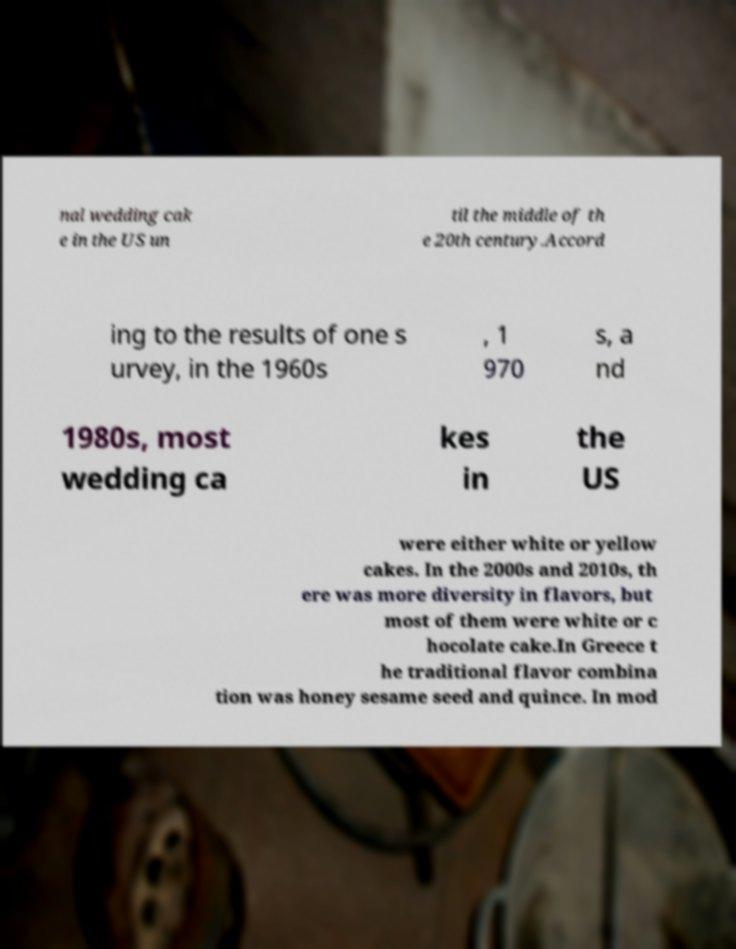There's text embedded in this image that I need extracted. Can you transcribe it verbatim? nal wedding cak e in the US un til the middle of th e 20th century.Accord ing to the results of one s urvey, in the 1960s , 1 970 s, a nd 1980s, most wedding ca kes in the US were either white or yellow cakes. In the 2000s and 2010s, th ere was more diversity in flavors, but most of them were white or c hocolate cake.In Greece t he traditional flavor combina tion was honey sesame seed and quince. In mod 